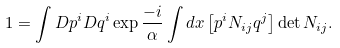<formula> <loc_0><loc_0><loc_500><loc_500>1 = \int D p ^ { i } D q ^ { i } \exp \frac { - i } { \alpha } \int d x \left [ p ^ { i } N _ { i j } q ^ { j } \right ] \det N _ { i j } .</formula> 